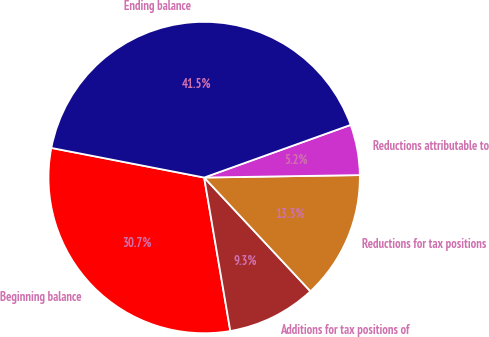Convert chart. <chart><loc_0><loc_0><loc_500><loc_500><pie_chart><fcel>Beginning balance<fcel>Additions for tax positions of<fcel>Reductions for tax positions<fcel>Reductions attributable to<fcel>Ending balance<nl><fcel>30.73%<fcel>9.27%<fcel>13.29%<fcel>5.24%<fcel>41.46%<nl></chart> 